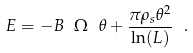Convert formula to latex. <formula><loc_0><loc_0><loc_500><loc_500>E = - B \ \Omega \ \theta + \frac { \pi \rho _ { s } \theta ^ { 2 } } { \ln ( L ) } \ .</formula> 